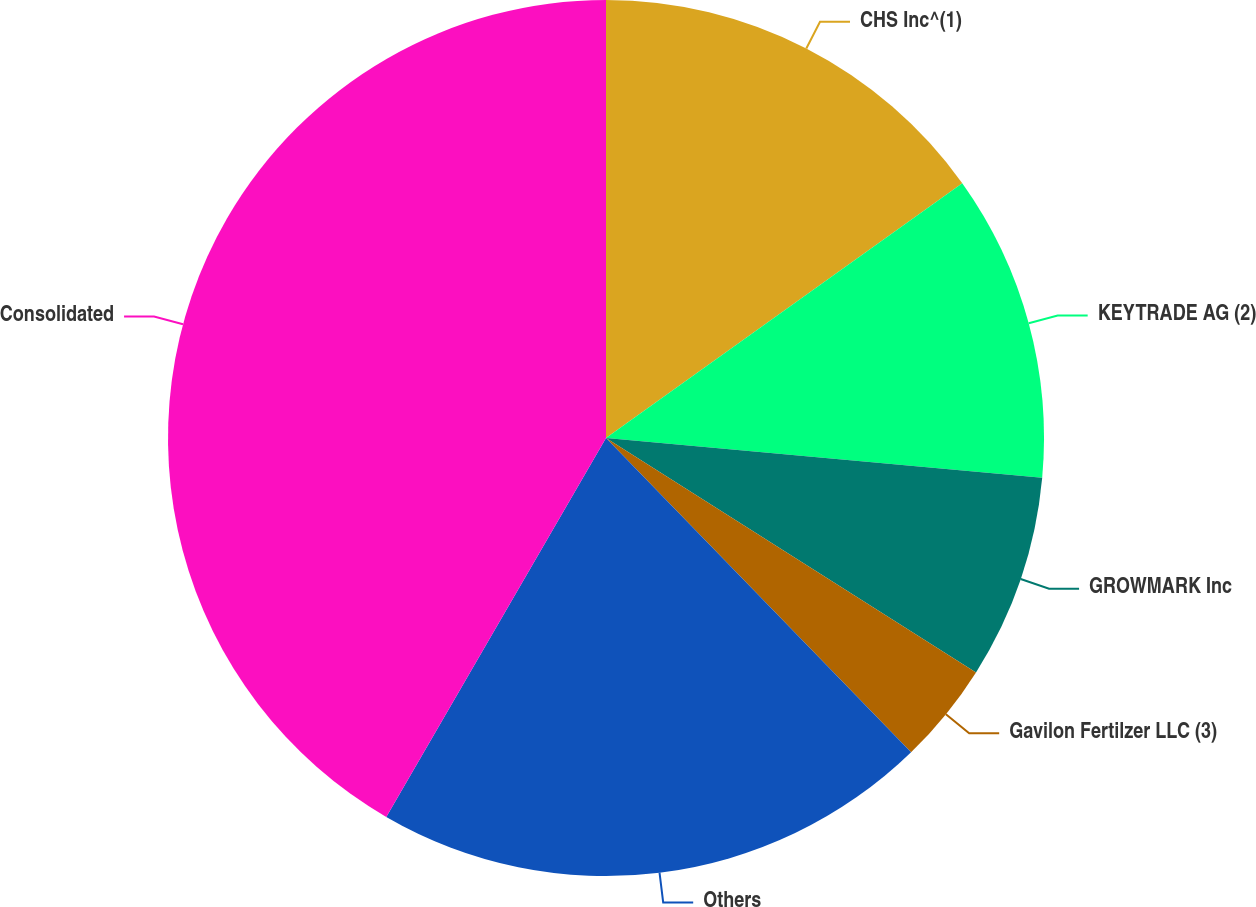Convert chart to OTSL. <chart><loc_0><loc_0><loc_500><loc_500><pie_chart><fcel>CHS Inc^(1)<fcel>KEYTRADE AG (2)<fcel>GROWMARK Inc<fcel>Gavilon Fertilzer LLC (3)<fcel>Others<fcel>Consolidated<nl><fcel>15.12%<fcel>11.33%<fcel>7.54%<fcel>3.75%<fcel>20.63%<fcel>41.64%<nl></chart> 